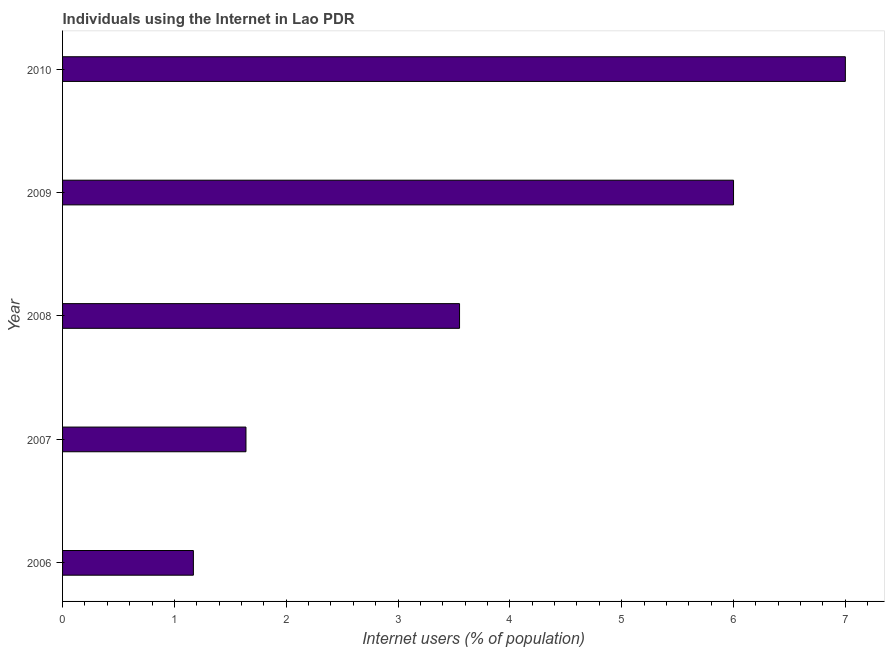Does the graph contain any zero values?
Your answer should be very brief. No. What is the title of the graph?
Your response must be concise. Individuals using the Internet in Lao PDR. What is the label or title of the X-axis?
Provide a short and direct response. Internet users (% of population). What is the number of internet users in 2008?
Your answer should be very brief. 3.55. Across all years, what is the minimum number of internet users?
Provide a short and direct response. 1.17. What is the sum of the number of internet users?
Offer a terse response. 19.36. What is the difference between the number of internet users in 2006 and 2010?
Ensure brevity in your answer.  -5.83. What is the average number of internet users per year?
Keep it short and to the point. 3.87. What is the median number of internet users?
Make the answer very short. 3.55. What is the ratio of the number of internet users in 2008 to that in 2010?
Your answer should be compact. 0.51. What is the difference between the highest and the lowest number of internet users?
Offer a very short reply. 5.83. In how many years, is the number of internet users greater than the average number of internet users taken over all years?
Provide a succinct answer. 2. How many years are there in the graph?
Ensure brevity in your answer.  5. What is the difference between two consecutive major ticks on the X-axis?
Provide a succinct answer. 1. Are the values on the major ticks of X-axis written in scientific E-notation?
Offer a terse response. No. What is the Internet users (% of population) in 2006?
Your answer should be very brief. 1.17. What is the Internet users (% of population) in 2007?
Keep it short and to the point. 1.64. What is the Internet users (% of population) of 2008?
Your answer should be very brief. 3.55. What is the difference between the Internet users (% of population) in 2006 and 2007?
Offer a very short reply. -0.47. What is the difference between the Internet users (% of population) in 2006 and 2008?
Provide a succinct answer. -2.38. What is the difference between the Internet users (% of population) in 2006 and 2009?
Provide a short and direct response. -4.83. What is the difference between the Internet users (% of population) in 2006 and 2010?
Your response must be concise. -5.83. What is the difference between the Internet users (% of population) in 2007 and 2008?
Make the answer very short. -1.91. What is the difference between the Internet users (% of population) in 2007 and 2009?
Your answer should be very brief. -4.36. What is the difference between the Internet users (% of population) in 2007 and 2010?
Your answer should be very brief. -5.36. What is the difference between the Internet users (% of population) in 2008 and 2009?
Offer a very short reply. -2.45. What is the difference between the Internet users (% of population) in 2008 and 2010?
Give a very brief answer. -3.45. What is the difference between the Internet users (% of population) in 2009 and 2010?
Keep it short and to the point. -1. What is the ratio of the Internet users (% of population) in 2006 to that in 2007?
Ensure brevity in your answer.  0.71. What is the ratio of the Internet users (% of population) in 2006 to that in 2008?
Provide a succinct answer. 0.33. What is the ratio of the Internet users (% of population) in 2006 to that in 2009?
Your response must be concise. 0.2. What is the ratio of the Internet users (% of population) in 2006 to that in 2010?
Your answer should be very brief. 0.17. What is the ratio of the Internet users (% of population) in 2007 to that in 2008?
Offer a very short reply. 0.46. What is the ratio of the Internet users (% of population) in 2007 to that in 2009?
Offer a terse response. 0.27. What is the ratio of the Internet users (% of population) in 2007 to that in 2010?
Offer a terse response. 0.23. What is the ratio of the Internet users (% of population) in 2008 to that in 2009?
Give a very brief answer. 0.59. What is the ratio of the Internet users (% of population) in 2008 to that in 2010?
Provide a short and direct response. 0.51. What is the ratio of the Internet users (% of population) in 2009 to that in 2010?
Offer a terse response. 0.86. 